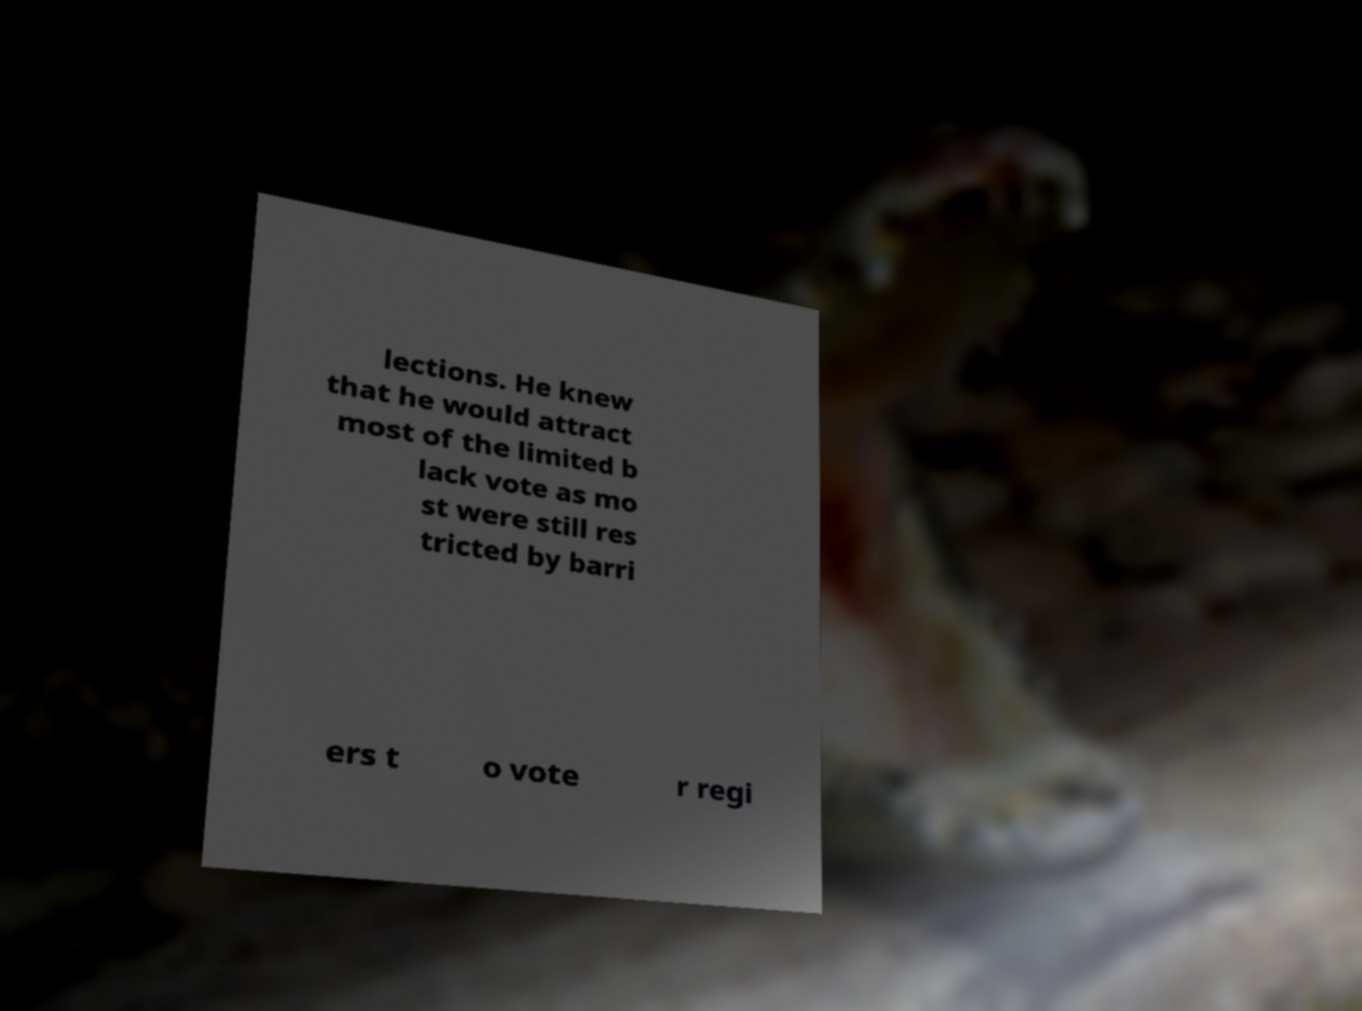Could you assist in decoding the text presented in this image and type it out clearly? lections. He knew that he would attract most of the limited b lack vote as mo st were still res tricted by barri ers t o vote r regi 